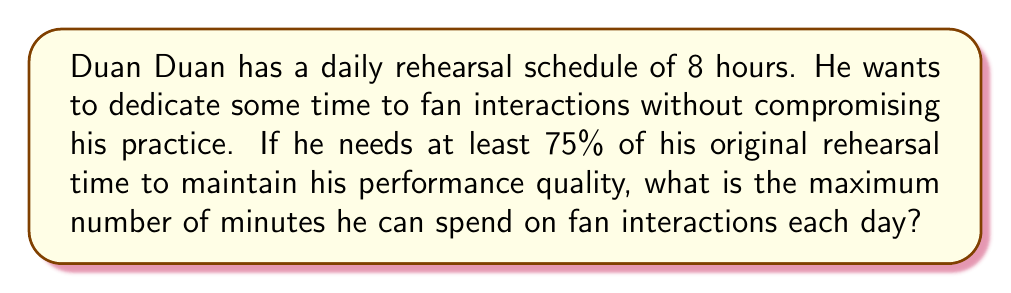Show me your answer to this math problem. Let's approach this step-by-step:

1) Duan Duan's original rehearsal time is 8 hours per day.

2) We need to convert this to minutes:
   $$ 8 \text{ hours} \times 60 \text{ minutes/hour} = 480 \text{ minutes} $$

3) He needs to maintain at least 75% of his original rehearsal time. Let's calculate this:
   $$ 480 \text{ minutes} \times 0.75 = 360 \text{ minutes} $$

4) This means the maximum time he can spend on fan interactions is the difference between his original rehearsal time and the minimum required rehearsal time:
   $$ 480 \text{ minutes} - 360 \text{ minutes} = 120 \text{ minutes} $$

5) Therefore, the maximum time Duan Duan can spend on fan interactions while maintaining his rehearsal schedule is 120 minutes or 2 hours per day.
Answer: 120 minutes 